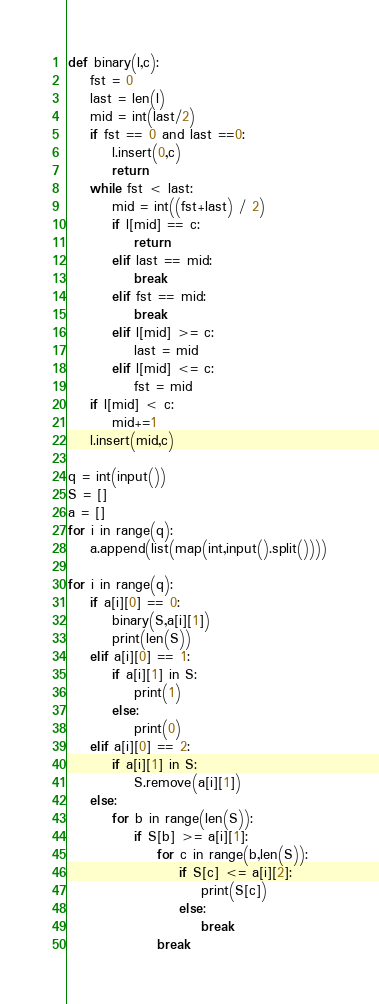<code> <loc_0><loc_0><loc_500><loc_500><_Python_>def binary(l,c):
    fst = 0
    last = len(l)
    mid = int(last/2)
    if fst == 0 and last ==0:
        l.insert(0,c)
        return
    while fst < last:
        mid = int((fst+last) / 2)
        if l[mid] == c:
            return
        elif last == mid:
            break
        elif fst == mid:
            break
        elif l[mid] >= c:
            last = mid
        elif l[mid] <= c:
            fst = mid
    if l[mid] < c:
        mid+=1
    l.insert(mid,c)

q = int(input())
S = []
a = []
for i in range(q):
    a.append(list(map(int,input().split())))

for i in range(q):
    if a[i][0] == 0:
        binary(S,a[i][1])
        print(len(S))
    elif a[i][0] == 1:
        if a[i][1] in S:
            print(1)
        else:
            print(0)
    elif a[i][0] == 2:
        if a[i][1] in S:
            S.remove(a[i][1])
    else:
        for b in range(len(S)):
            if S[b] >= a[i][1]:
                for c in range(b,len(S)):
                    if S[c] <= a[i][2]:
                        print(S[c])
                    else:
                        break
                break
</code> 